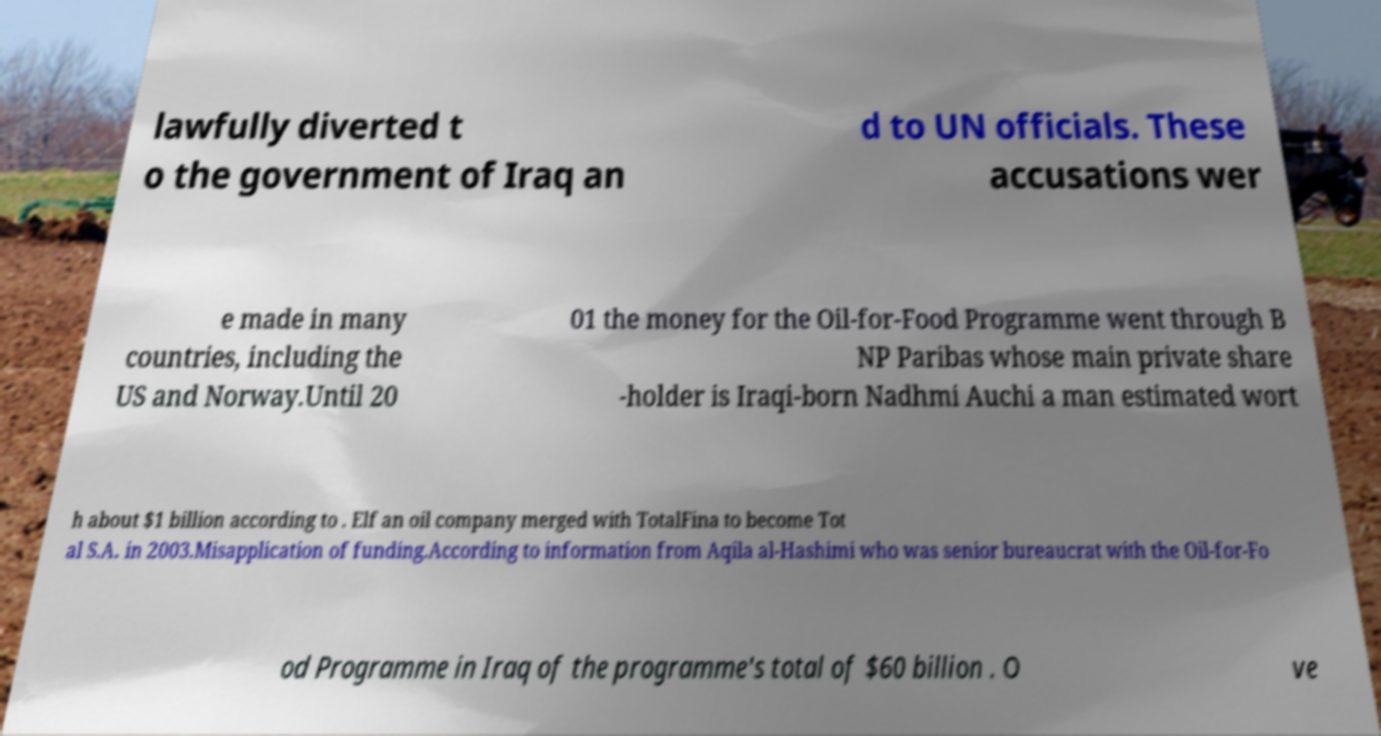Can you accurately transcribe the text from the provided image for me? lawfully diverted t o the government of Iraq an d to UN officials. These accusations wer e made in many countries, including the US and Norway.Until 20 01 the money for the Oil-for-Food Programme went through B NP Paribas whose main private share -holder is Iraqi-born Nadhmi Auchi a man estimated wort h about $1 billion according to . Elf an oil company merged with TotalFina to become Tot al S.A. in 2003.Misapplication of funding.According to information from Aqila al-Hashimi who was senior bureaucrat with the Oil-for-Fo od Programme in Iraq of the programme's total of $60 billion . O ve 